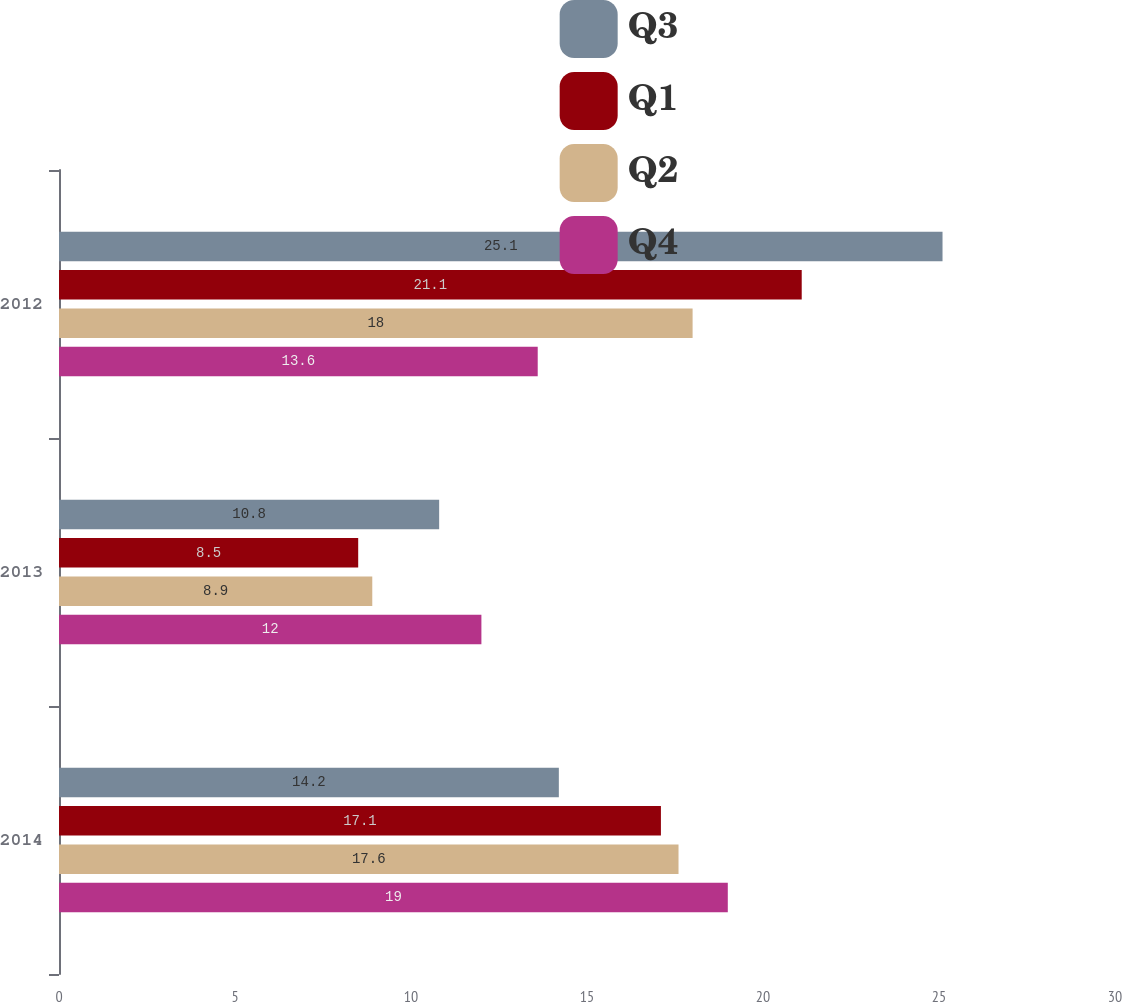Convert chart. <chart><loc_0><loc_0><loc_500><loc_500><stacked_bar_chart><ecel><fcel>2014<fcel>2013<fcel>2012<nl><fcel>Q3<fcel>14.2<fcel>10.8<fcel>25.1<nl><fcel>Q1<fcel>17.1<fcel>8.5<fcel>21.1<nl><fcel>Q2<fcel>17.6<fcel>8.9<fcel>18<nl><fcel>Q4<fcel>19<fcel>12<fcel>13.6<nl></chart> 